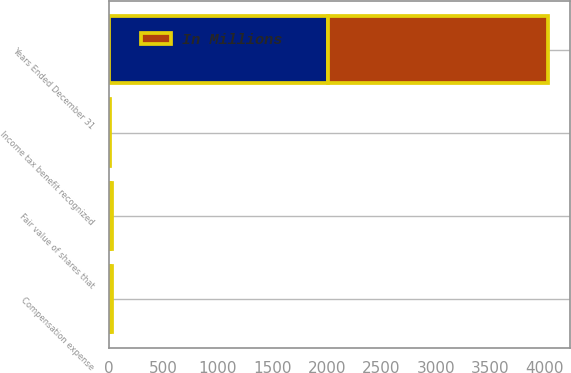Convert chart to OTSL. <chart><loc_0><loc_0><loc_500><loc_500><stacked_bar_chart><ecel><fcel>Years Ended December 31<fcel>Fair value of shares that<fcel>Compensation expense<fcel>Income tax benefit recognized<nl><fcel>nan<fcel>2014<fcel>16<fcel>14<fcel>5<nl><fcel>In Millions<fcel>2013<fcel>10<fcel>14<fcel>5<nl></chart> 